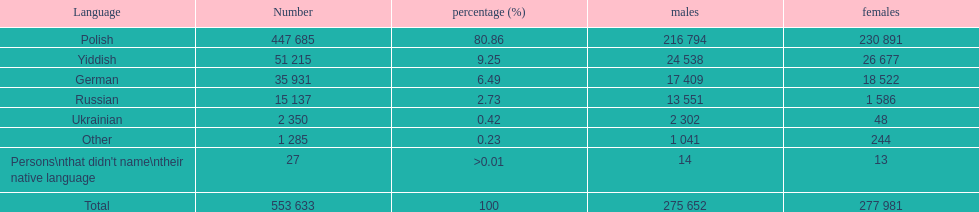How many male and female german speakers are there? 35931. 